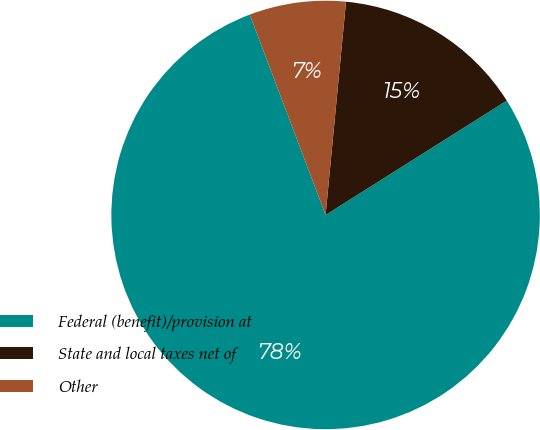Convert chart to OTSL. <chart><loc_0><loc_0><loc_500><loc_500><pie_chart><fcel>Federal (benefit)/provision at<fcel>State and local taxes net of<fcel>Other<nl><fcel>78.2%<fcel>14.52%<fcel>7.28%<nl></chart> 